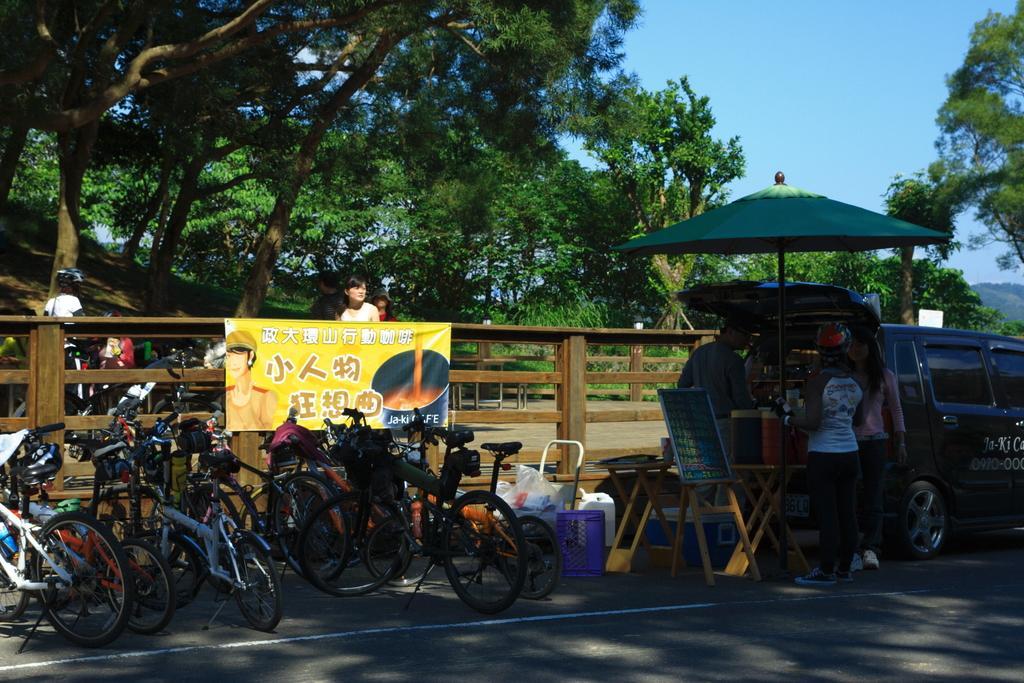Please provide a concise description of this image. There are bicycles, car, and three persons on the road. Here we can see a table, board, plastic cover, basket, box, bottles, umbrella, fence, banner, and few persons. In the background we can see trees and this is sky. 